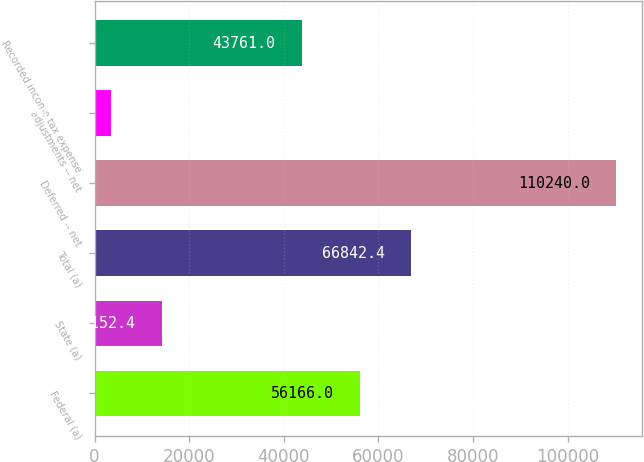Convert chart to OTSL. <chart><loc_0><loc_0><loc_500><loc_500><bar_chart><fcel>Federal (a)<fcel>State (a)<fcel>Total (a)<fcel>Deferred -- net<fcel>adjustments -- net<fcel>Recorded income tax expense<nl><fcel>56166<fcel>14152.4<fcel>66842.4<fcel>110240<fcel>3476<fcel>43761<nl></chart> 